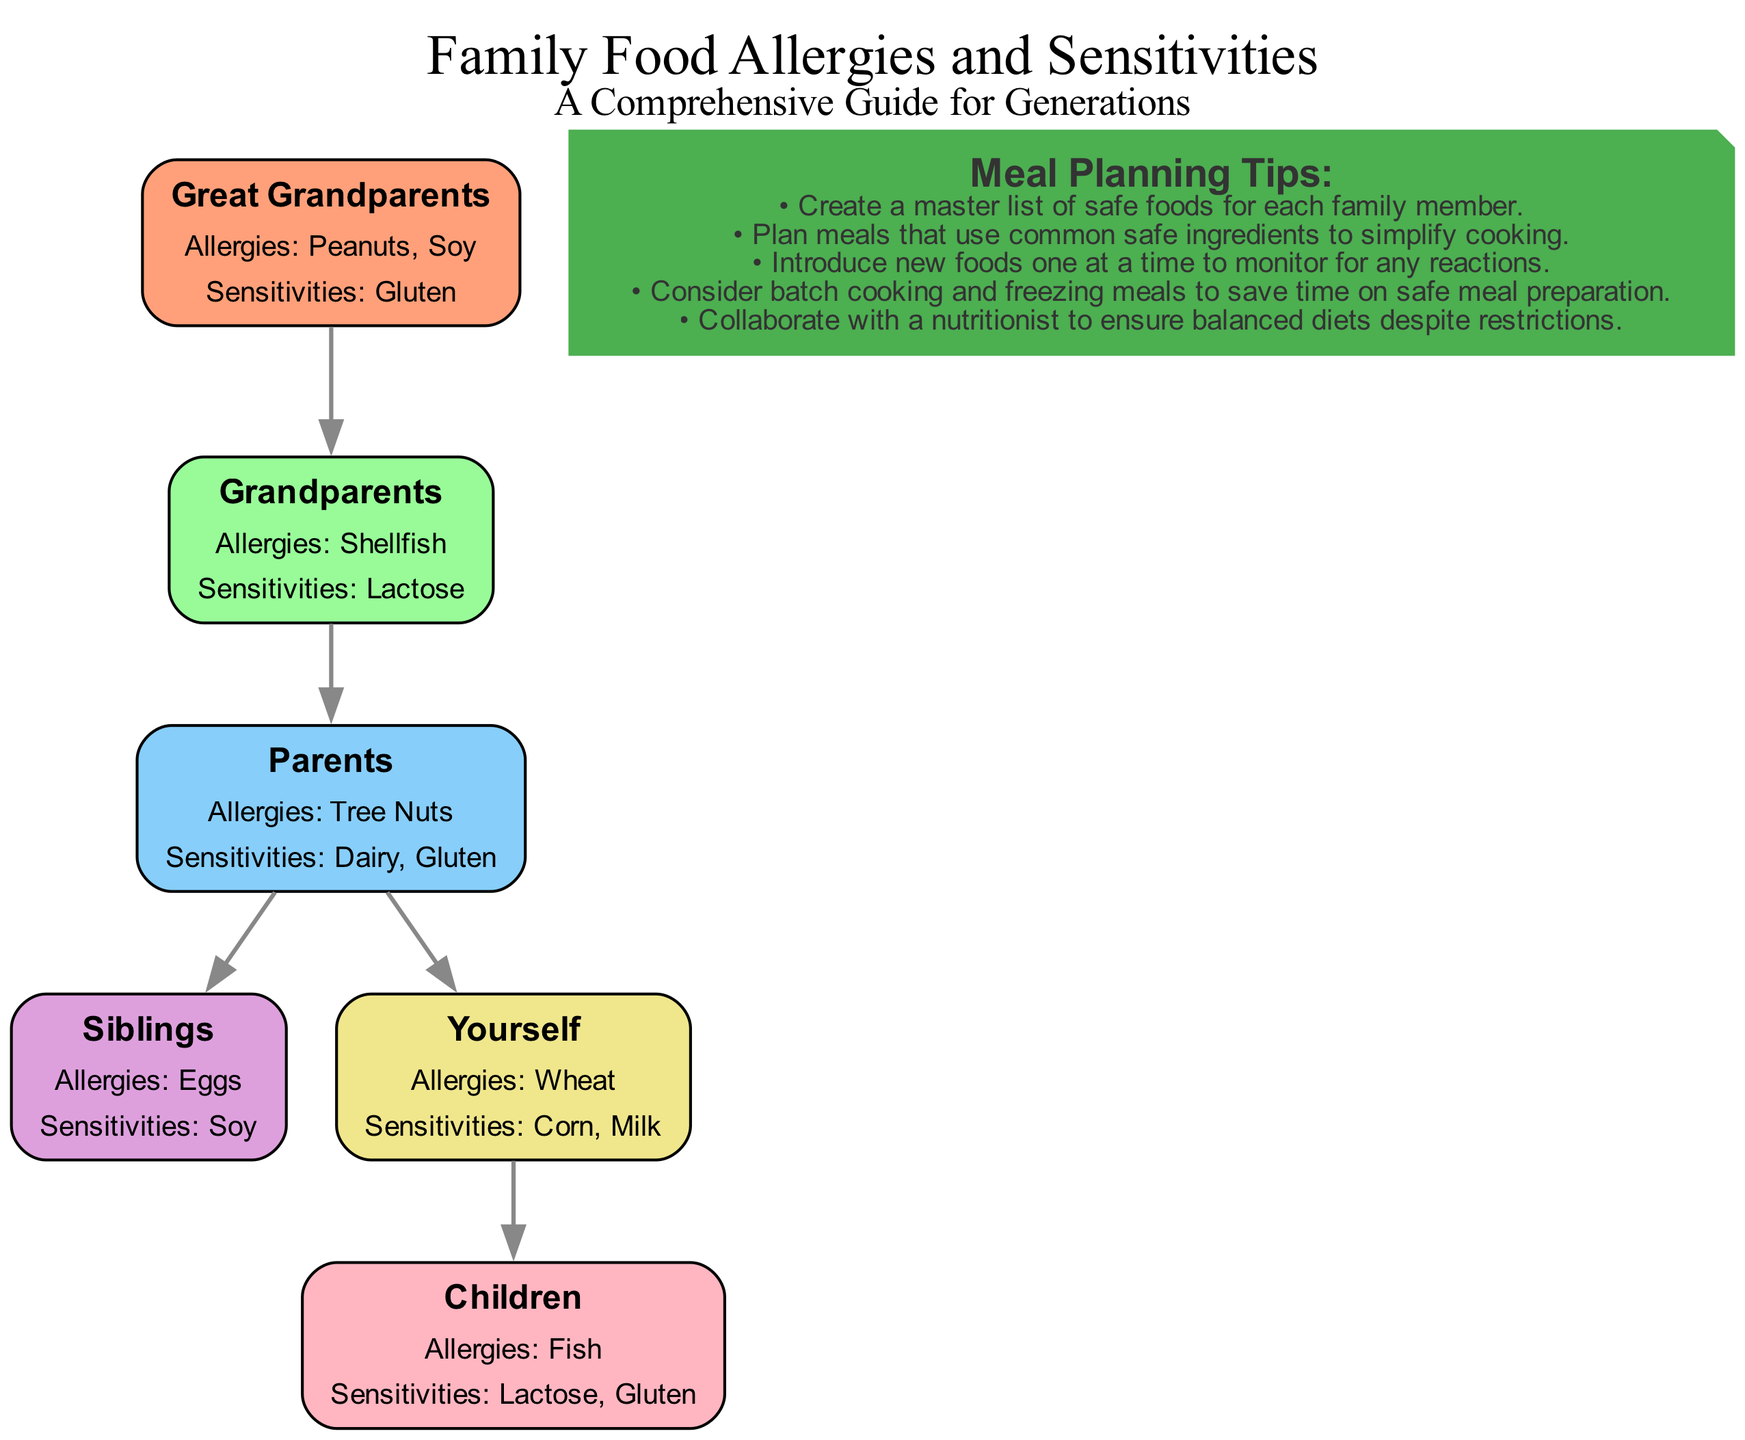What allergies do your siblings have? The diagram indicates that "Siblings" have "Eggs" as their allergy. By locating the node labeled "Siblings" in the diagram and referencing the allergy information provided, we find that the listed allergy is "Eggs."
Answer: Eggs What sensitivities are shared between you and your parents? The diagram shows that both "Parents" and "Yourself" have "Gluten" as a sensitivity. By examining the nodes for both "Parents" and "Yourself," we can see that "Gluten" is mentioned under both categories, highlighting it as a shared sensitivity.
Answer: Gluten How many total allergies are reported in the family tree? To determine the total number of allergies, we count the unique allergies across all nodes: Great Grandparents have 2, Grandparents have 1, Parents have 1, Siblings have 1, Yourself have 1, and Children have 1. Summing these gives 2 + 1 + 1 + 1 + 1 + 1 = 7 total allergies.
Answer: 7 Who is the only member with a fish allergy? Looking at the diagram, we can see that only "Children" have "Fish" listed as their allergy. Checking the allergies for each family member confirms that this allergy is unique to "Children."
Answer: Children What is the relationship between great grandparents and parents? The relationship between "Great Grandparents" and "Parents" is that "Great Grandparents" are the ancestors of "Parents," connected by an edge in the diagram that indicates generational lineage. This shows that the direct link is from "Great Grandparents" to "Grandparents," and then from "Grandparents" to "Parents."
Answer: Ancestors What is the sensitivity of your children? The diagram indicates that "Children" have "Lactose" and "Gluten" as their sensitivities. By referencing the "Children" node in the family tree, we observe these sensitivities listed under their information.
Answer: Lactose, Gluten What meal planning tip suggests introducing new foods? The diagram shows that one meal planning tip suggests "Introduce new foods one at a time to monitor for any reactions." This information is part of the meal planning tips provided at the bottom of the diagram and indicates a cautious approach to food introduction.
Answer: Introduce new foods one at a time How many levels are depicted in this family tree? The family tree comprises 6 nodes, with levels including Great Grandparents, Grandparents, Parents, Siblings, Yourself, and Children. Each of these represents a distinct generational level, creating 6 levels in total from the oldest to the youngest.
Answer: 6 